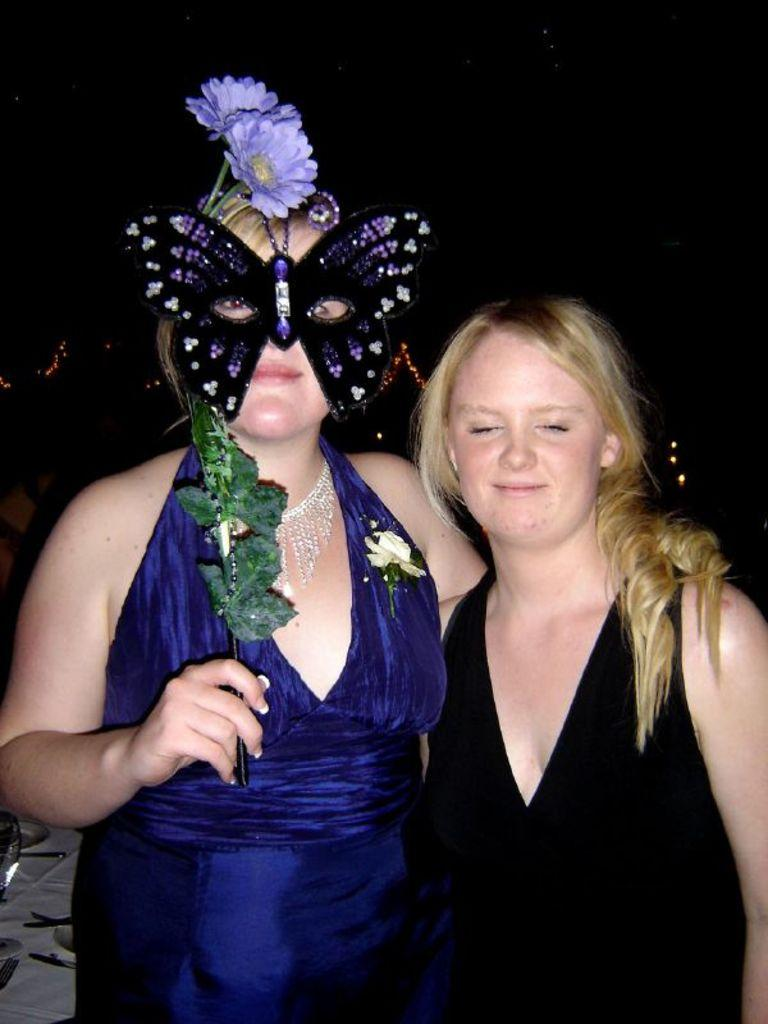How many women are in the image? There are two women in the image. What is unique about one of the women's appearance? One of the women is wearing a butterfly mask. What type of objects can be seen in the image besides the women? There are two flowers in the image. What can be said about the lighting in the image? There are lights visible in the image. What is the rate at which the flowers are growing in the image? The rate at which the flowers are growing cannot be determined from the image, as it is a still photograph. What way is the wrench being used in the image? There is no wrench present in the image. 